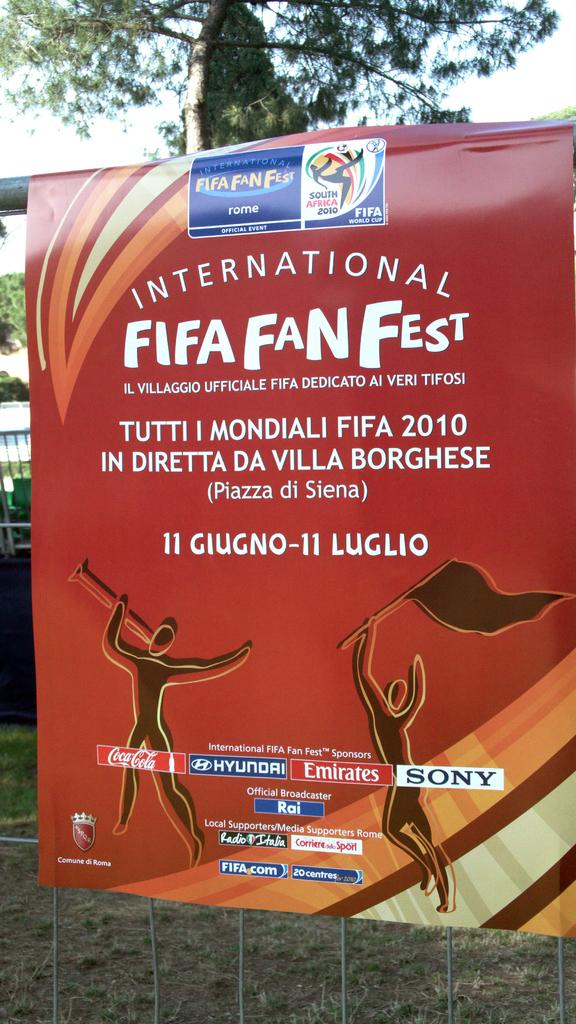<image>
Render a clear and concise summary of the photo. A poster advertises the International FIFA Fan Fest. 